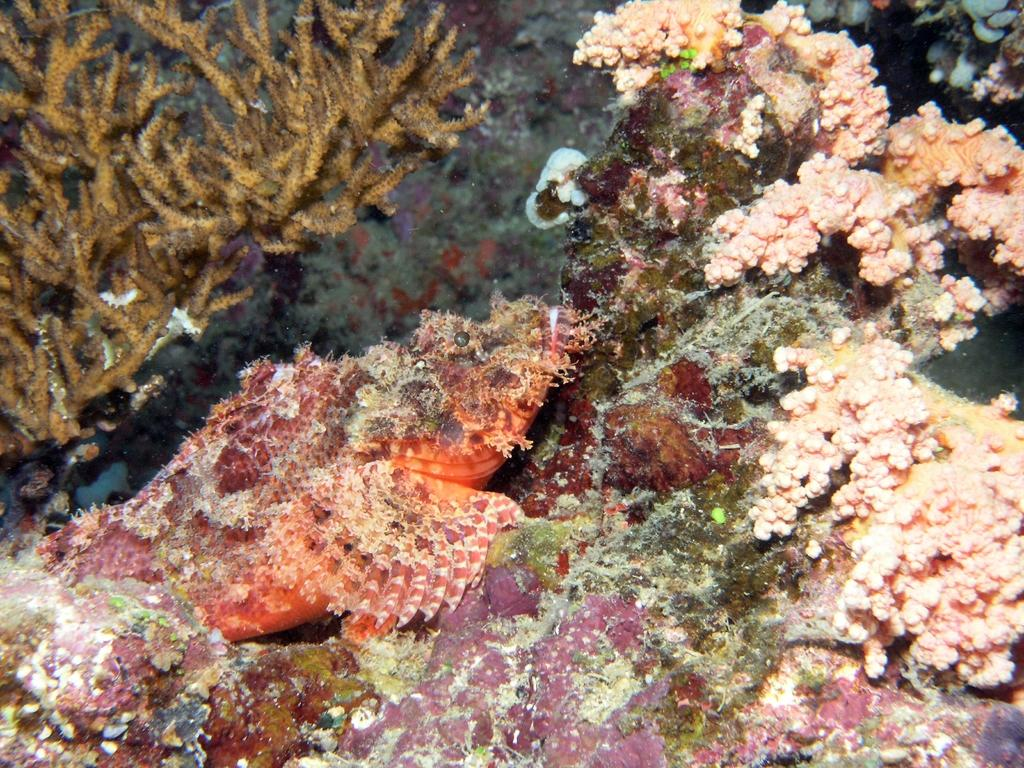What type of plants can be seen in the image? There are sea plants in the image. What type of juice is being squeezed from the sea plants in the image? There is no juice being squeezed from the sea plants in the image. In fact, there is no appliance or wrench present in the image either. 